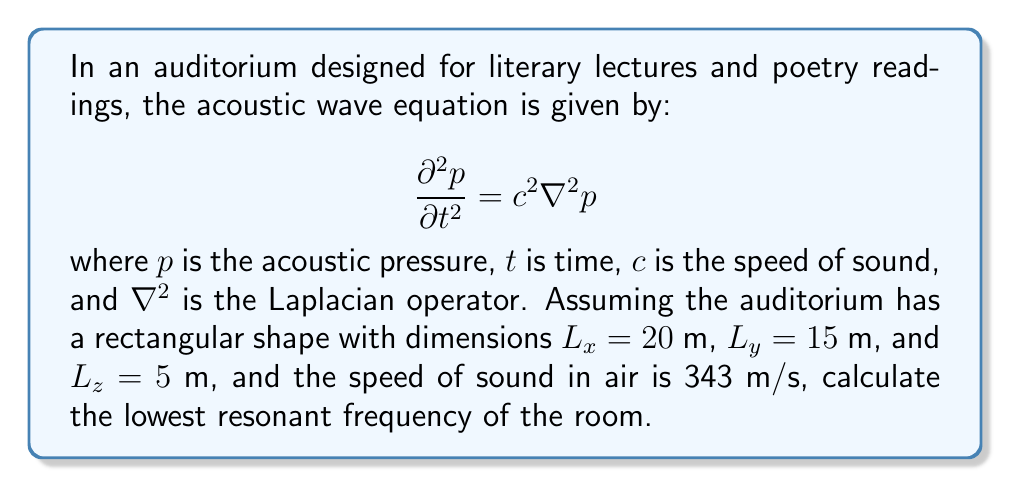Give your solution to this math problem. To solve this problem, we'll follow these steps:

1) The resonant frequencies of a rectangular room are given by the formula:

   $$f_{n_x,n_y,n_z} = \frac{c}{2} \sqrt{\left(\frac{n_x}{L_x}\right)^2 + \left(\frac{n_y}{L_y}\right)^2 + \left(\frac{n_z}{L_z}\right)^2}$$

   where $n_x$, $n_y$, and $n_z$ are non-negative integers.

2) The lowest resonant frequency occurs when $n_x = 1$, $n_y = 0$, and $n_z = 0$. This corresponds to the fundamental mode along the longest dimension of the room.

3) Substituting these values into the equation:

   $$f_{1,0,0} = \frac{343}{2} \sqrt{\left(\frac{1}{20}\right)^2 + \left(\frac{0}{15}\right)^2 + \left(\frac{0}{5}\right)^2}$$

4) Simplifying:

   $$f_{1,0,0} = \frac{343}{2} \sqrt{\frac{1}{400}} = \frac{343}{2} \cdot \frac{1}{20} = \frac{343}{40}$$

5) Calculating the final result:

   $$f_{1,0,0} = 8.575 \text{ Hz}$$

This frequency corresponds to the fundamental mode along the length of the auditorium, which would create a standing wave with a wavelength twice the length of the room.
Answer: 8.575 Hz 